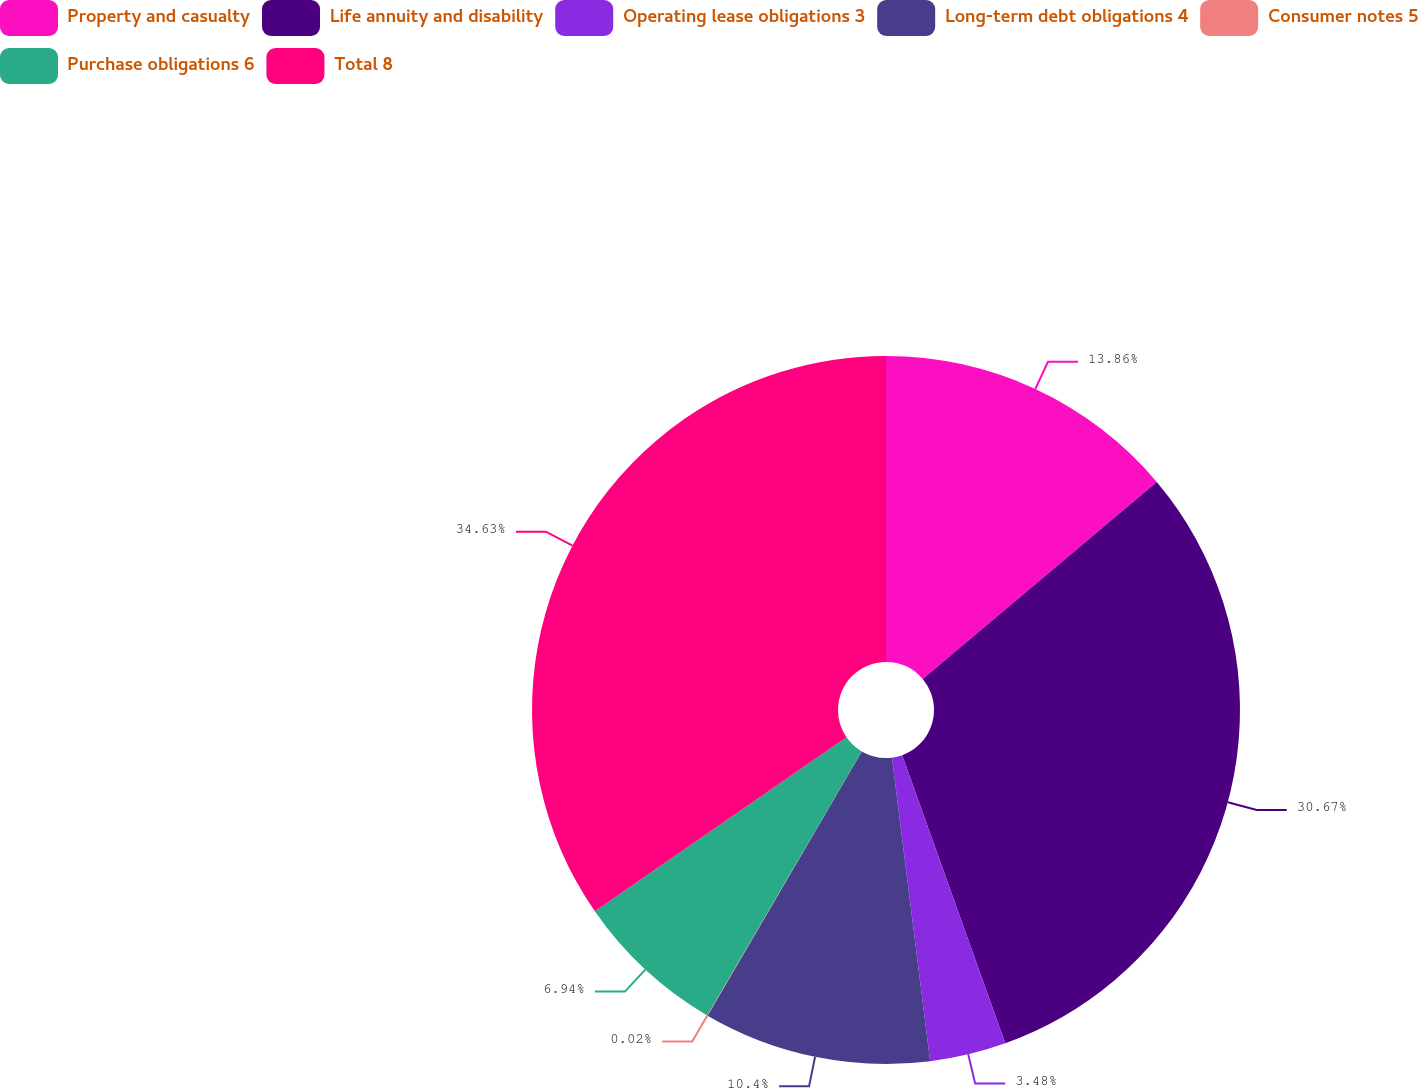Convert chart to OTSL. <chart><loc_0><loc_0><loc_500><loc_500><pie_chart><fcel>Property and casualty<fcel>Life annuity and disability<fcel>Operating lease obligations 3<fcel>Long-term debt obligations 4<fcel>Consumer notes 5<fcel>Purchase obligations 6<fcel>Total 8<nl><fcel>13.86%<fcel>30.67%<fcel>3.48%<fcel>10.4%<fcel>0.02%<fcel>6.94%<fcel>34.63%<nl></chart> 